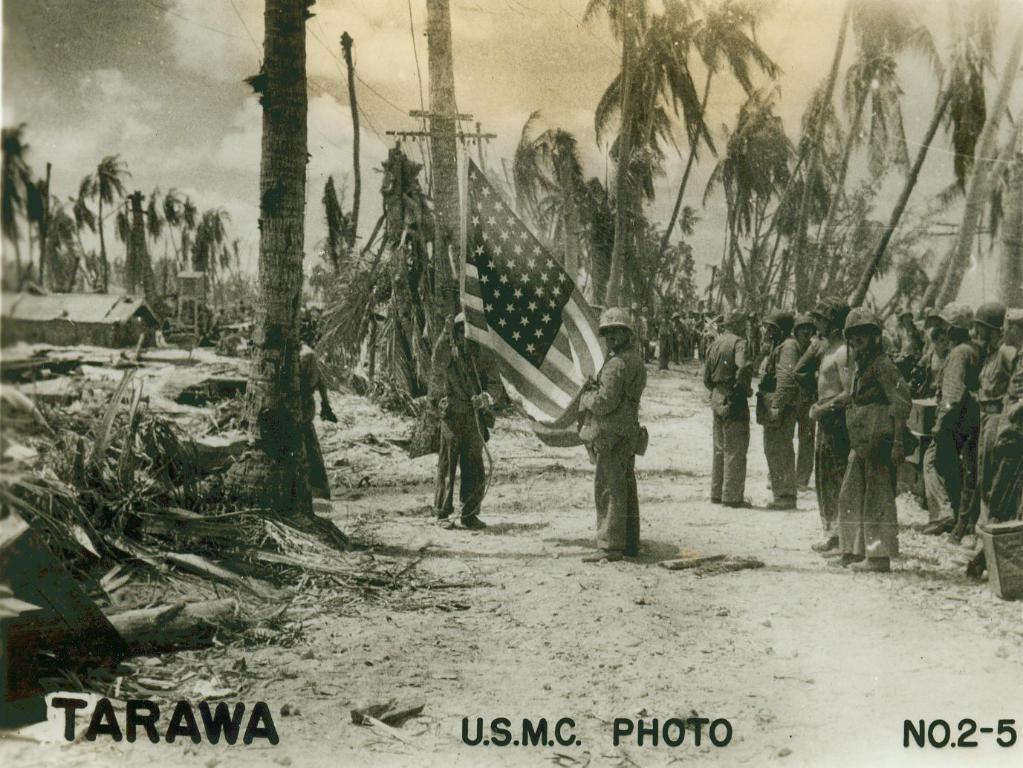What can be found at the bottom of the image? There is text at the bottom of the image. What is the main subject in the middle of the image? There is a group of soldiers and a flag in the middle of the image. What type of vegetation is present in the middle of the image? There are trees in the middle of the image. What is visible at the top of the image? The sky is visible at the top of the image. When was the image taken? The image was taken during the day. What type of fish can be seen swimming near the soldiers in the image? There are no fish present in the image; it features a group of soldiers, a flag, and trees. How does the sister of the photographer feel about the image? There is no information about the photographer's sister or her feelings in the image or the provided facts. 